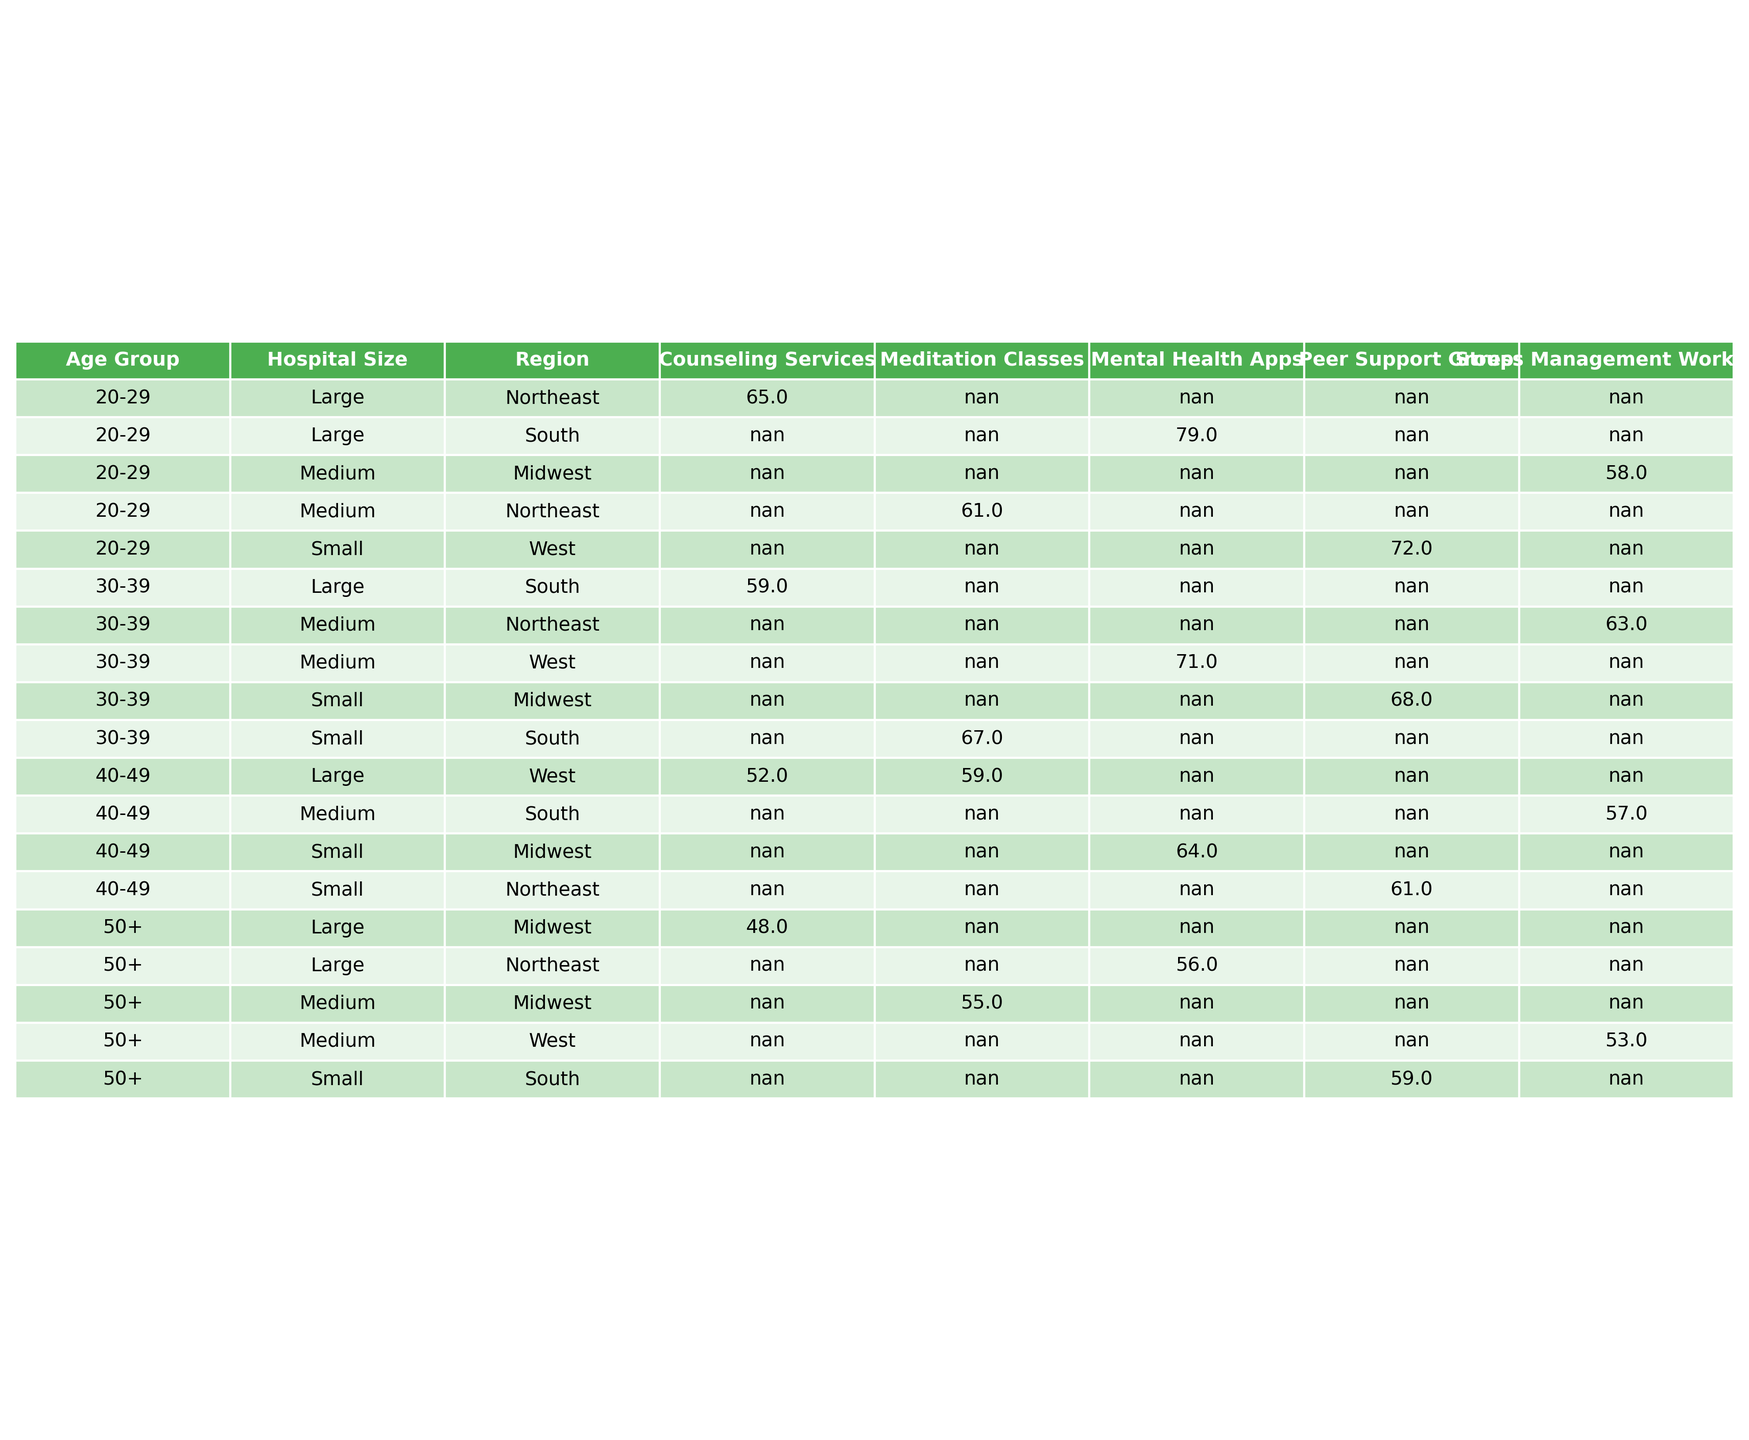What is the utilization rate of counseling services for the 20-29 age group? In the table under the "20-29" age group and "Counseling Services," the utilization rate is listed as 65%.
Answer: 65% Which age group has the highest utilization rate for peer support groups? Looking at the "Peer Support Groups" row in the table, the "20-29" age group shows the highest utilization rate at 72%.
Answer: 20-29 What is the average utilization rate of mental health apps across all age groups? To find the average, sum the utilization rates for mental health apps: (79 + 71 + 64 + 56) = 270. There are 4 age groups, so divide 270 by 4, which gives 67.5.
Answer: 67.5 Is the utilization rate of stress management workshops higher for the 30-39 age group compared to the 40-49 age group? For the 30-39 age group, the utilization rate for stress management workshops is 63%. For the 40-49 age group, it is 57%. Since 63% is greater than 57%, the statement is true.
Answer: Yes What is the difference in utilization rates of meditation classes between the 30-39 and 50+ age groups? The utilization rate of meditation classes for the 30-39 age group is 67%, and for the 50+ age group, it is 55%. The difference is calculated as 67 - 55 = 12.
Answer: 12 Which resource type has the lowest utilization rate for the 40-49 age group? In the 40-49 age group, the utilization rates for different resources are: Counseling Services (52%), Stress Management Workshops (57%), Peer Support Groups (61%), so Counseling Services has the lowest at 52%.
Answer: Counseling Services How do utilization rates of counseling services for the 30-39 and 50+ age groups compare? The utilization rate for the 30-39 age group is 59%, while for the 50+ age group it is 48%. Comparing these, 59% is higher than 48%.
Answer: 30-39 has a higher rate What is the total utilization rate of all support resources for the 20-29 age group? The utilization rates for the 20-29 age group across different resources are: Counseling Services (65%), Stress Management Workshops (58%), Peer Support Groups (72%), Mental Health Apps (79%), and Meditation Classes (61%). Total = 65 + 58 + 72 + 79 + 61 = 335.
Answer: 335 Which region has the highest utilization rate for stress management workshops among the age groups? In the table, the Midwest region has a utilization rate of 58% for the 20-29 age group, 63% for the 30-39 age group, and 57% for the 40-49 age group. The South region has 57% for the 40-49 age group and the Northeast has 63% for the 30-39 age group. The highest utilization in the table across regions is 63% for the 30-39 age group in the Northeast.
Answer: Northeast Do small hospitals have a higher average utilization rate for peer support groups compared to large hospitals? For small hospitals: the utilization rates are 72% for the 20-29 age group, 68% for the 30-39 age group, and 61% for the 40-49 age group, totaling 72 + 68 + 61 = 201%. For large hospitals: the utilization rate is 65% for the 20-29 age group and 59% for the 30-39 age group totaling 65 + 59 = 124%. The average for small hospitals is 201/3 = 67%, while for large hospitals it is 124/2 = 62%.
Answer: Yes 